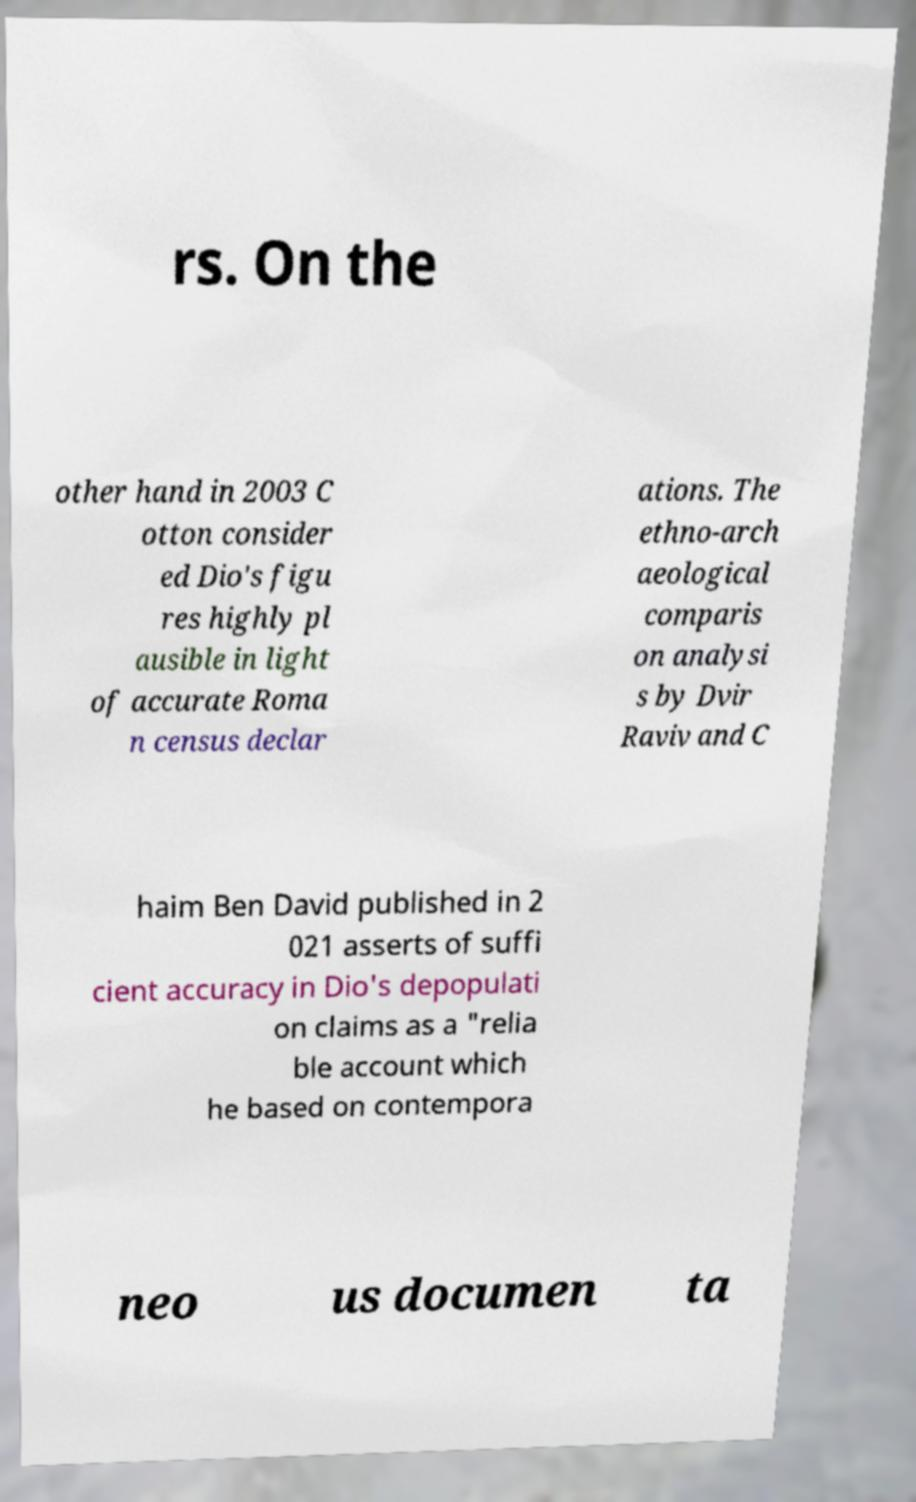What messages or text are displayed in this image? I need them in a readable, typed format. rs. On the other hand in 2003 C otton consider ed Dio's figu res highly pl ausible in light of accurate Roma n census declar ations. The ethno-arch aeological comparis on analysi s by Dvir Raviv and C haim Ben David published in 2 021 asserts of suffi cient accuracy in Dio's depopulati on claims as a "relia ble account which he based on contempora neo us documen ta 